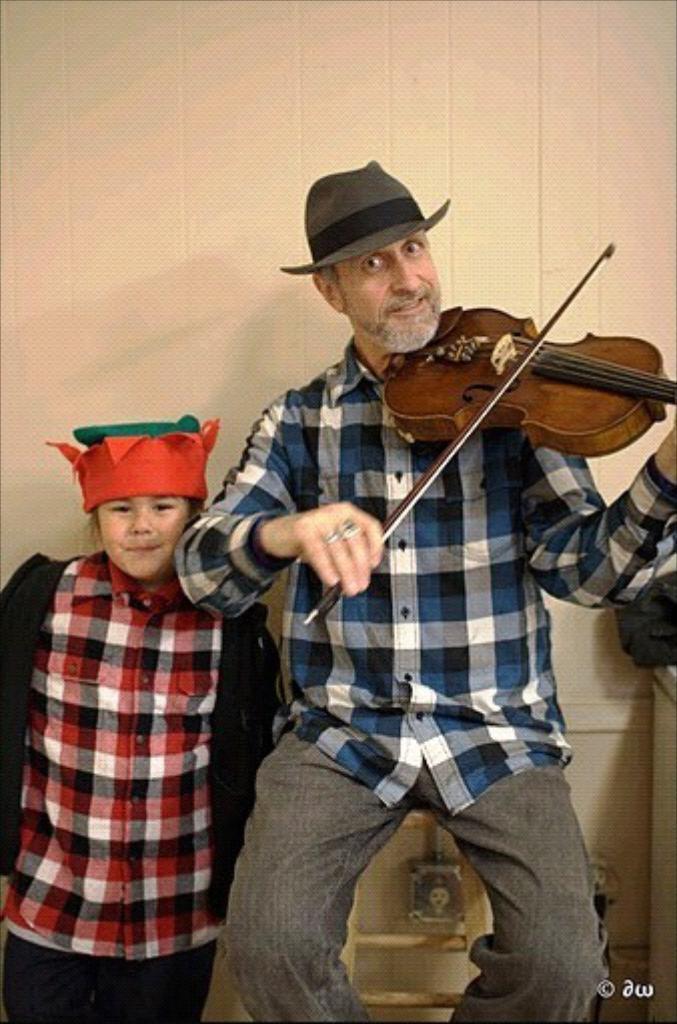In one or two sentences, can you explain what this image depicts? This person standing and this person sitting and holding musical instrument. On the background we can see wall. 